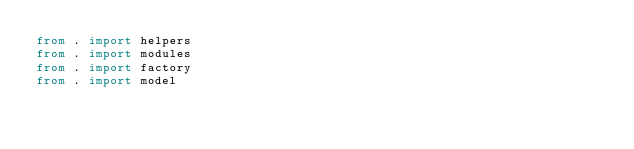Convert code to text. <code><loc_0><loc_0><loc_500><loc_500><_Python_>from . import helpers
from . import modules
from . import factory
from . import model</code> 